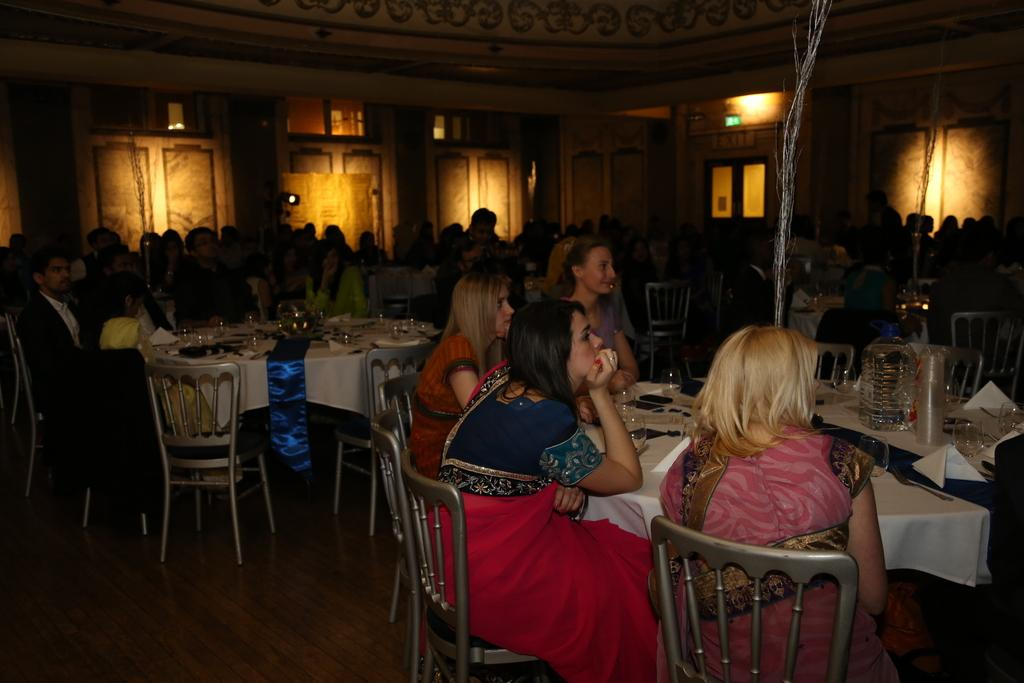What are the people in the image doing? The people in the image are sitting on chairs. What objects are present in the image besides the people? There are tables in the image. What can be seen on the tables? There are glasses on the tables in the image. What type of pest can be seen crawling on the glasses in the image? There are no pests visible in the image, and no pests are mentioned in the provided facts. 